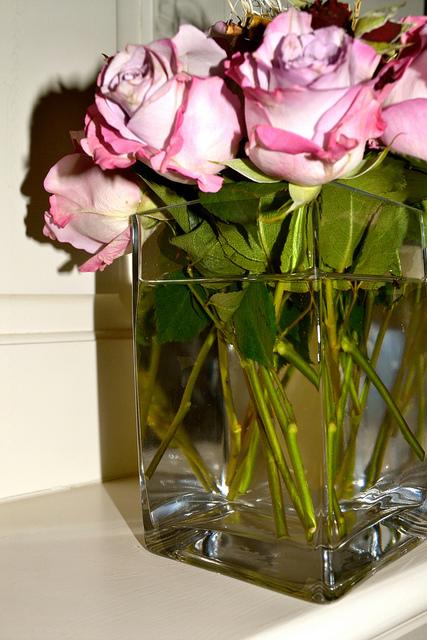Are these flowers beginning to wilt?
Write a very short answer. No. Is this a round vase?
Short answer required. No. What color are the flowers?
Short answer required. Pink. 